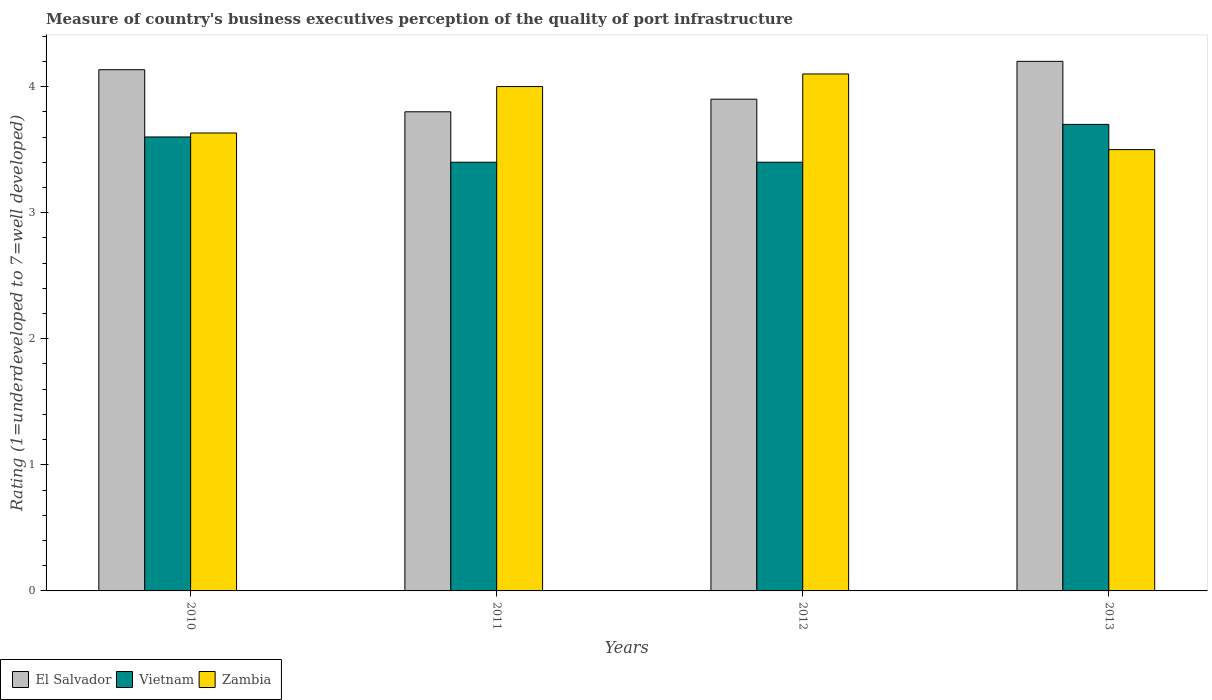Are the number of bars on each tick of the X-axis equal?
Your answer should be very brief. Yes. How many bars are there on the 3rd tick from the left?
Your answer should be compact. 3. Across all years, what is the minimum ratings of the quality of port infrastructure in El Salvador?
Offer a very short reply. 3.8. In which year was the ratings of the quality of port infrastructure in Vietnam maximum?
Offer a terse response. 2013. In which year was the ratings of the quality of port infrastructure in Vietnam minimum?
Provide a succinct answer. 2011. What is the total ratings of the quality of port infrastructure in Zambia in the graph?
Your answer should be compact. 15.23. What is the difference between the ratings of the quality of port infrastructure in Zambia in 2012 and that in 2013?
Your answer should be very brief. 0.6. What is the difference between the ratings of the quality of port infrastructure in Vietnam in 2011 and the ratings of the quality of port infrastructure in Zambia in 2012?
Ensure brevity in your answer.  -0.7. What is the average ratings of the quality of port infrastructure in Vietnam per year?
Offer a very short reply. 3.53. In the year 2010, what is the difference between the ratings of the quality of port infrastructure in Vietnam and ratings of the quality of port infrastructure in Zambia?
Your response must be concise. -0.03. In how many years, is the ratings of the quality of port infrastructure in Zambia greater than 2.8?
Ensure brevity in your answer.  4. What is the ratio of the ratings of the quality of port infrastructure in Zambia in 2010 to that in 2012?
Your answer should be compact. 0.89. Is the ratings of the quality of port infrastructure in El Salvador in 2012 less than that in 2013?
Make the answer very short. Yes. What is the difference between the highest and the second highest ratings of the quality of port infrastructure in Zambia?
Your answer should be compact. 0.1. What is the difference between the highest and the lowest ratings of the quality of port infrastructure in Vietnam?
Your answer should be compact. 0.3. What does the 3rd bar from the left in 2012 represents?
Make the answer very short. Zambia. What does the 1st bar from the right in 2012 represents?
Provide a short and direct response. Zambia. Is it the case that in every year, the sum of the ratings of the quality of port infrastructure in Vietnam and ratings of the quality of port infrastructure in El Salvador is greater than the ratings of the quality of port infrastructure in Zambia?
Make the answer very short. Yes. What is the difference between two consecutive major ticks on the Y-axis?
Your answer should be compact. 1. Are the values on the major ticks of Y-axis written in scientific E-notation?
Provide a short and direct response. No. Does the graph contain any zero values?
Your answer should be very brief. No. Where does the legend appear in the graph?
Ensure brevity in your answer.  Bottom left. How many legend labels are there?
Your answer should be very brief. 3. How are the legend labels stacked?
Ensure brevity in your answer.  Horizontal. What is the title of the graph?
Ensure brevity in your answer.  Measure of country's business executives perception of the quality of port infrastructure. Does "Kosovo" appear as one of the legend labels in the graph?
Provide a succinct answer. No. What is the label or title of the X-axis?
Make the answer very short. Years. What is the label or title of the Y-axis?
Make the answer very short. Rating (1=underdeveloped to 7=well developed). What is the Rating (1=underdeveloped to 7=well developed) in El Salvador in 2010?
Make the answer very short. 4.13. What is the Rating (1=underdeveloped to 7=well developed) in Vietnam in 2010?
Ensure brevity in your answer.  3.6. What is the Rating (1=underdeveloped to 7=well developed) in Zambia in 2010?
Ensure brevity in your answer.  3.63. What is the Rating (1=underdeveloped to 7=well developed) of Vietnam in 2011?
Your answer should be compact. 3.4. Across all years, what is the maximum Rating (1=underdeveloped to 7=well developed) of Vietnam?
Your answer should be compact. 3.7. Across all years, what is the minimum Rating (1=underdeveloped to 7=well developed) of Vietnam?
Provide a short and direct response. 3.4. Across all years, what is the minimum Rating (1=underdeveloped to 7=well developed) of Zambia?
Provide a succinct answer. 3.5. What is the total Rating (1=underdeveloped to 7=well developed) in El Salvador in the graph?
Offer a very short reply. 16.03. What is the total Rating (1=underdeveloped to 7=well developed) of Vietnam in the graph?
Make the answer very short. 14.1. What is the total Rating (1=underdeveloped to 7=well developed) of Zambia in the graph?
Provide a succinct answer. 15.23. What is the difference between the Rating (1=underdeveloped to 7=well developed) of El Salvador in 2010 and that in 2011?
Your answer should be compact. 0.33. What is the difference between the Rating (1=underdeveloped to 7=well developed) of Vietnam in 2010 and that in 2011?
Make the answer very short. 0.2. What is the difference between the Rating (1=underdeveloped to 7=well developed) of Zambia in 2010 and that in 2011?
Offer a very short reply. -0.37. What is the difference between the Rating (1=underdeveloped to 7=well developed) of El Salvador in 2010 and that in 2012?
Make the answer very short. 0.23. What is the difference between the Rating (1=underdeveloped to 7=well developed) in Vietnam in 2010 and that in 2012?
Offer a very short reply. 0.2. What is the difference between the Rating (1=underdeveloped to 7=well developed) of Zambia in 2010 and that in 2012?
Make the answer very short. -0.47. What is the difference between the Rating (1=underdeveloped to 7=well developed) of El Salvador in 2010 and that in 2013?
Keep it short and to the point. -0.07. What is the difference between the Rating (1=underdeveloped to 7=well developed) in Vietnam in 2010 and that in 2013?
Your answer should be compact. -0.1. What is the difference between the Rating (1=underdeveloped to 7=well developed) of Zambia in 2010 and that in 2013?
Offer a very short reply. 0.13. What is the difference between the Rating (1=underdeveloped to 7=well developed) of El Salvador in 2011 and that in 2012?
Provide a short and direct response. -0.1. What is the difference between the Rating (1=underdeveloped to 7=well developed) of Zambia in 2011 and that in 2012?
Make the answer very short. -0.1. What is the difference between the Rating (1=underdeveloped to 7=well developed) in Zambia in 2011 and that in 2013?
Your answer should be very brief. 0.5. What is the difference between the Rating (1=underdeveloped to 7=well developed) of El Salvador in 2012 and that in 2013?
Provide a succinct answer. -0.3. What is the difference between the Rating (1=underdeveloped to 7=well developed) in Vietnam in 2012 and that in 2013?
Provide a succinct answer. -0.3. What is the difference between the Rating (1=underdeveloped to 7=well developed) of Zambia in 2012 and that in 2013?
Offer a very short reply. 0.6. What is the difference between the Rating (1=underdeveloped to 7=well developed) in El Salvador in 2010 and the Rating (1=underdeveloped to 7=well developed) in Vietnam in 2011?
Make the answer very short. 0.73. What is the difference between the Rating (1=underdeveloped to 7=well developed) of El Salvador in 2010 and the Rating (1=underdeveloped to 7=well developed) of Zambia in 2011?
Ensure brevity in your answer.  0.13. What is the difference between the Rating (1=underdeveloped to 7=well developed) in Vietnam in 2010 and the Rating (1=underdeveloped to 7=well developed) in Zambia in 2011?
Give a very brief answer. -0.4. What is the difference between the Rating (1=underdeveloped to 7=well developed) in El Salvador in 2010 and the Rating (1=underdeveloped to 7=well developed) in Vietnam in 2012?
Provide a short and direct response. 0.73. What is the difference between the Rating (1=underdeveloped to 7=well developed) of El Salvador in 2010 and the Rating (1=underdeveloped to 7=well developed) of Zambia in 2012?
Provide a succinct answer. 0.03. What is the difference between the Rating (1=underdeveloped to 7=well developed) in Vietnam in 2010 and the Rating (1=underdeveloped to 7=well developed) in Zambia in 2012?
Give a very brief answer. -0.5. What is the difference between the Rating (1=underdeveloped to 7=well developed) in El Salvador in 2010 and the Rating (1=underdeveloped to 7=well developed) in Vietnam in 2013?
Your answer should be very brief. 0.43. What is the difference between the Rating (1=underdeveloped to 7=well developed) of El Salvador in 2010 and the Rating (1=underdeveloped to 7=well developed) of Zambia in 2013?
Provide a succinct answer. 0.63. What is the difference between the Rating (1=underdeveloped to 7=well developed) of Vietnam in 2010 and the Rating (1=underdeveloped to 7=well developed) of Zambia in 2013?
Provide a succinct answer. 0.1. What is the difference between the Rating (1=underdeveloped to 7=well developed) of El Salvador in 2011 and the Rating (1=underdeveloped to 7=well developed) of Vietnam in 2012?
Offer a very short reply. 0.4. What is the difference between the Rating (1=underdeveloped to 7=well developed) of El Salvador in 2011 and the Rating (1=underdeveloped to 7=well developed) of Zambia in 2012?
Provide a short and direct response. -0.3. What is the difference between the Rating (1=underdeveloped to 7=well developed) in El Salvador in 2011 and the Rating (1=underdeveloped to 7=well developed) in Vietnam in 2013?
Ensure brevity in your answer.  0.1. What is the difference between the Rating (1=underdeveloped to 7=well developed) in El Salvador in 2012 and the Rating (1=underdeveloped to 7=well developed) in Vietnam in 2013?
Provide a short and direct response. 0.2. What is the difference between the Rating (1=underdeveloped to 7=well developed) of El Salvador in 2012 and the Rating (1=underdeveloped to 7=well developed) of Zambia in 2013?
Your answer should be very brief. 0.4. What is the average Rating (1=underdeveloped to 7=well developed) of El Salvador per year?
Provide a succinct answer. 4.01. What is the average Rating (1=underdeveloped to 7=well developed) of Vietnam per year?
Offer a very short reply. 3.53. What is the average Rating (1=underdeveloped to 7=well developed) of Zambia per year?
Your response must be concise. 3.81. In the year 2010, what is the difference between the Rating (1=underdeveloped to 7=well developed) of El Salvador and Rating (1=underdeveloped to 7=well developed) of Vietnam?
Provide a short and direct response. 0.53. In the year 2010, what is the difference between the Rating (1=underdeveloped to 7=well developed) of El Salvador and Rating (1=underdeveloped to 7=well developed) of Zambia?
Your answer should be compact. 0.5. In the year 2010, what is the difference between the Rating (1=underdeveloped to 7=well developed) in Vietnam and Rating (1=underdeveloped to 7=well developed) in Zambia?
Keep it short and to the point. -0.03. In the year 2011, what is the difference between the Rating (1=underdeveloped to 7=well developed) of El Salvador and Rating (1=underdeveloped to 7=well developed) of Zambia?
Make the answer very short. -0.2. In the year 2011, what is the difference between the Rating (1=underdeveloped to 7=well developed) of Vietnam and Rating (1=underdeveloped to 7=well developed) of Zambia?
Give a very brief answer. -0.6. In the year 2012, what is the difference between the Rating (1=underdeveloped to 7=well developed) in Vietnam and Rating (1=underdeveloped to 7=well developed) in Zambia?
Ensure brevity in your answer.  -0.7. In the year 2013, what is the difference between the Rating (1=underdeveloped to 7=well developed) of El Salvador and Rating (1=underdeveloped to 7=well developed) of Zambia?
Provide a succinct answer. 0.7. In the year 2013, what is the difference between the Rating (1=underdeveloped to 7=well developed) of Vietnam and Rating (1=underdeveloped to 7=well developed) of Zambia?
Provide a short and direct response. 0.2. What is the ratio of the Rating (1=underdeveloped to 7=well developed) of El Salvador in 2010 to that in 2011?
Keep it short and to the point. 1.09. What is the ratio of the Rating (1=underdeveloped to 7=well developed) in Vietnam in 2010 to that in 2011?
Provide a short and direct response. 1.06. What is the ratio of the Rating (1=underdeveloped to 7=well developed) of Zambia in 2010 to that in 2011?
Offer a very short reply. 0.91. What is the ratio of the Rating (1=underdeveloped to 7=well developed) in El Salvador in 2010 to that in 2012?
Keep it short and to the point. 1.06. What is the ratio of the Rating (1=underdeveloped to 7=well developed) in Vietnam in 2010 to that in 2012?
Offer a very short reply. 1.06. What is the ratio of the Rating (1=underdeveloped to 7=well developed) of Zambia in 2010 to that in 2012?
Keep it short and to the point. 0.89. What is the ratio of the Rating (1=underdeveloped to 7=well developed) of El Salvador in 2010 to that in 2013?
Your response must be concise. 0.98. What is the ratio of the Rating (1=underdeveloped to 7=well developed) in Vietnam in 2010 to that in 2013?
Your answer should be very brief. 0.97. What is the ratio of the Rating (1=underdeveloped to 7=well developed) of Zambia in 2010 to that in 2013?
Ensure brevity in your answer.  1.04. What is the ratio of the Rating (1=underdeveloped to 7=well developed) of El Salvador in 2011 to that in 2012?
Offer a very short reply. 0.97. What is the ratio of the Rating (1=underdeveloped to 7=well developed) in Vietnam in 2011 to that in 2012?
Offer a very short reply. 1. What is the ratio of the Rating (1=underdeveloped to 7=well developed) of Zambia in 2011 to that in 2012?
Ensure brevity in your answer.  0.98. What is the ratio of the Rating (1=underdeveloped to 7=well developed) of El Salvador in 2011 to that in 2013?
Provide a short and direct response. 0.9. What is the ratio of the Rating (1=underdeveloped to 7=well developed) in Vietnam in 2011 to that in 2013?
Your answer should be compact. 0.92. What is the ratio of the Rating (1=underdeveloped to 7=well developed) in El Salvador in 2012 to that in 2013?
Provide a succinct answer. 0.93. What is the ratio of the Rating (1=underdeveloped to 7=well developed) in Vietnam in 2012 to that in 2013?
Offer a very short reply. 0.92. What is the ratio of the Rating (1=underdeveloped to 7=well developed) in Zambia in 2012 to that in 2013?
Give a very brief answer. 1.17. What is the difference between the highest and the second highest Rating (1=underdeveloped to 7=well developed) in El Salvador?
Offer a very short reply. 0.07. What is the difference between the highest and the second highest Rating (1=underdeveloped to 7=well developed) of Vietnam?
Provide a short and direct response. 0.1. What is the difference between the highest and the second highest Rating (1=underdeveloped to 7=well developed) in Zambia?
Ensure brevity in your answer.  0.1. 